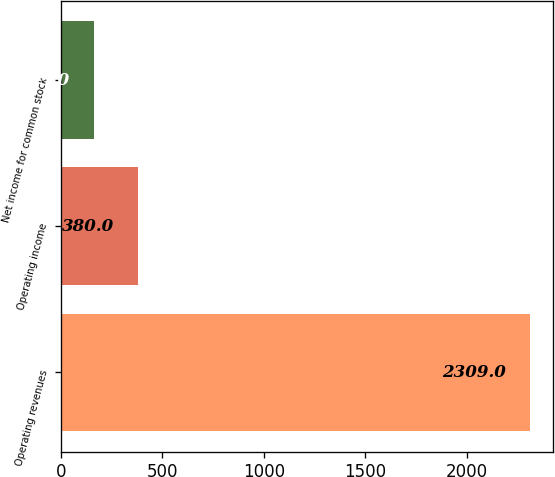Convert chart to OTSL. <chart><loc_0><loc_0><loc_500><loc_500><bar_chart><fcel>Operating revenues<fcel>Operating income<fcel>Net income for common stock<nl><fcel>2309<fcel>380<fcel>163<nl></chart> 